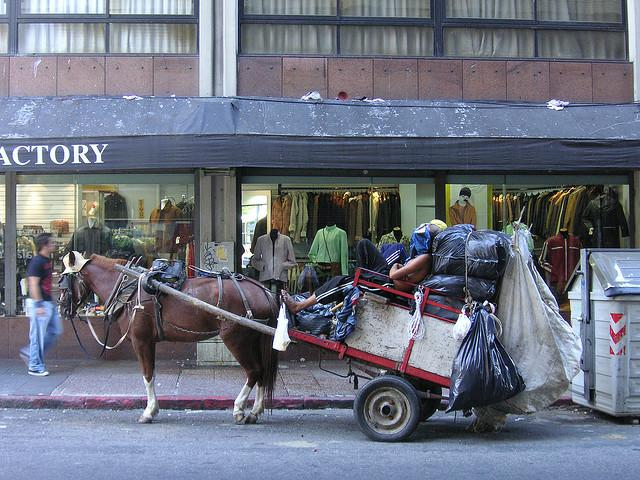What item here makes the horse go forward focusing? blinders 